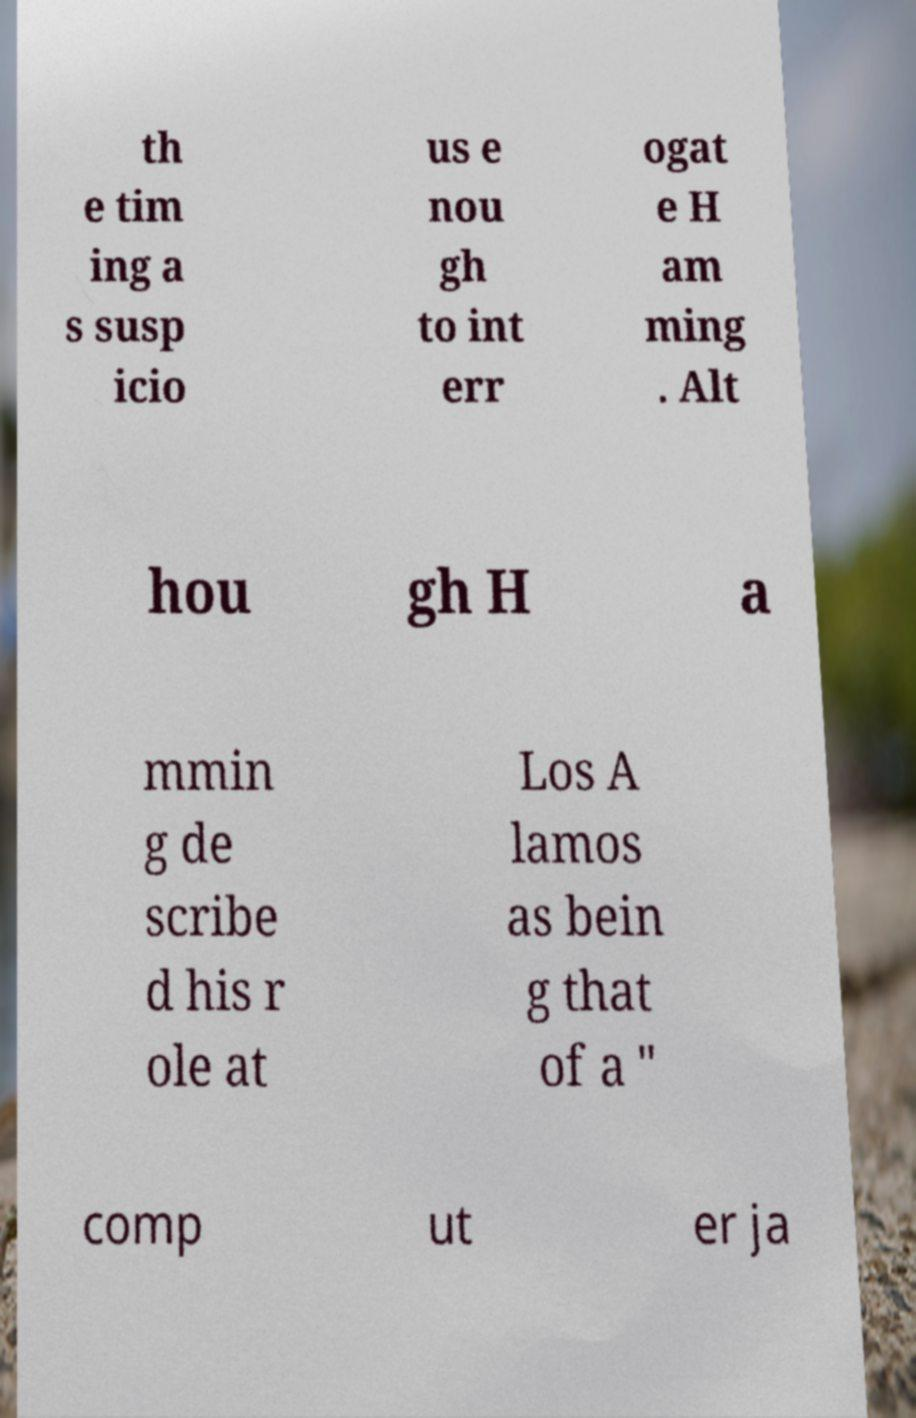There's text embedded in this image that I need extracted. Can you transcribe it verbatim? th e tim ing a s susp icio us e nou gh to int err ogat e H am ming . Alt hou gh H a mmin g de scribe d his r ole at Los A lamos as bein g that of a " comp ut er ja 